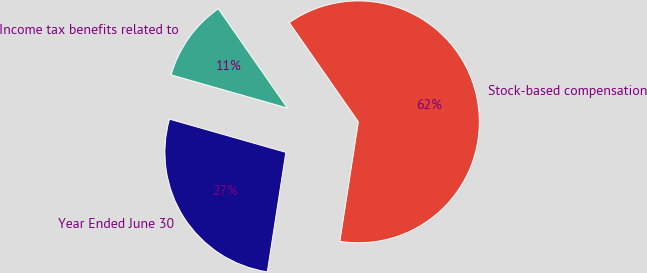<chart> <loc_0><loc_0><loc_500><loc_500><pie_chart><fcel>Year Ended June 30<fcel>Stock-based compensation<fcel>Income tax benefits related to<nl><fcel>26.97%<fcel>62.13%<fcel>10.9%<nl></chart> 